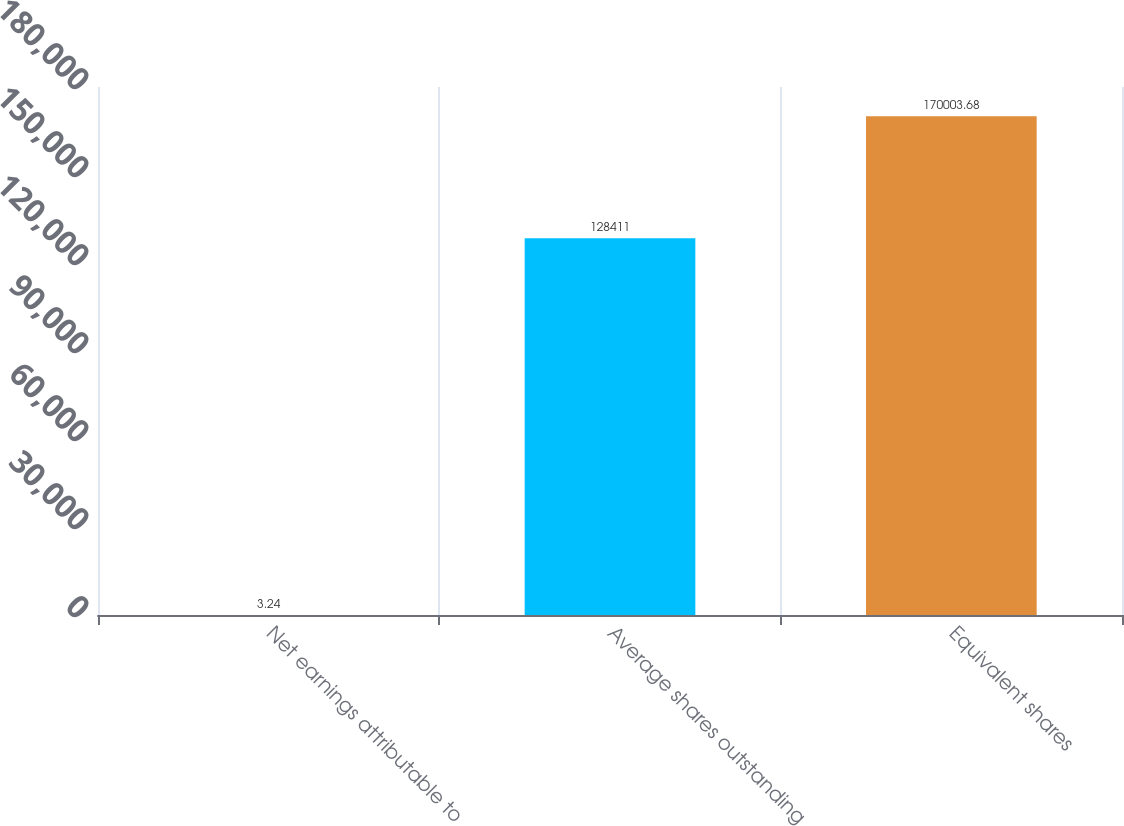Convert chart to OTSL. <chart><loc_0><loc_0><loc_500><loc_500><bar_chart><fcel>Net earnings attributable to<fcel>Average shares outstanding<fcel>Equivalent shares<nl><fcel>3.24<fcel>128411<fcel>170004<nl></chart> 